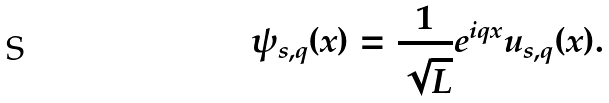Convert formula to latex. <formula><loc_0><loc_0><loc_500><loc_500>\psi _ { s , q } ( x ) = \frac { 1 } { \sqrt { L } } e ^ { i q x } u _ { s , q } ( x ) .</formula> 